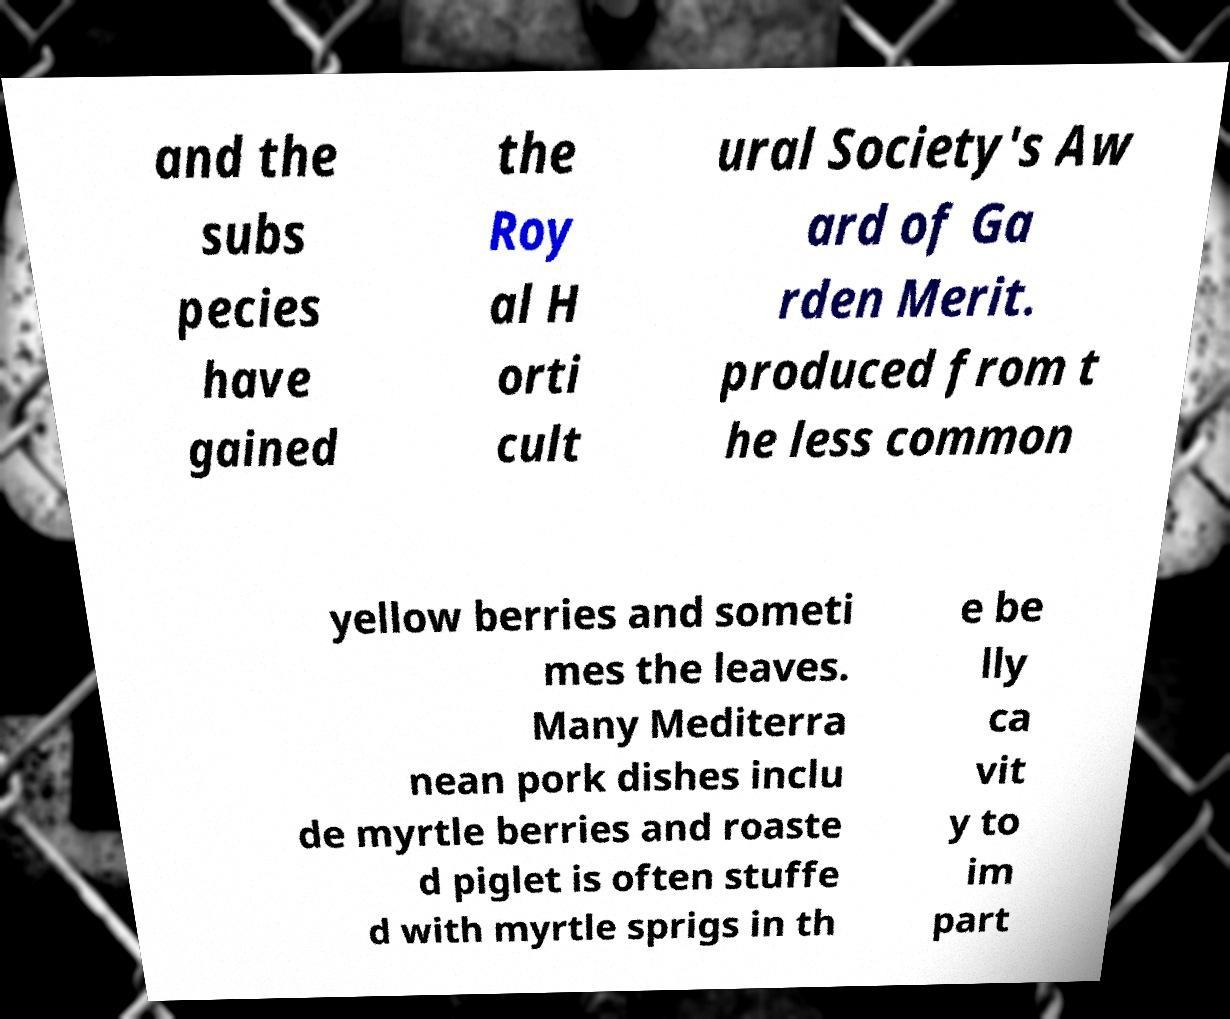Can you read and provide the text displayed in the image?This photo seems to have some interesting text. Can you extract and type it out for me? and the subs pecies have gained the Roy al H orti cult ural Society's Aw ard of Ga rden Merit. produced from t he less common yellow berries and someti mes the leaves. Many Mediterra nean pork dishes inclu de myrtle berries and roaste d piglet is often stuffe d with myrtle sprigs in th e be lly ca vit y to im part 